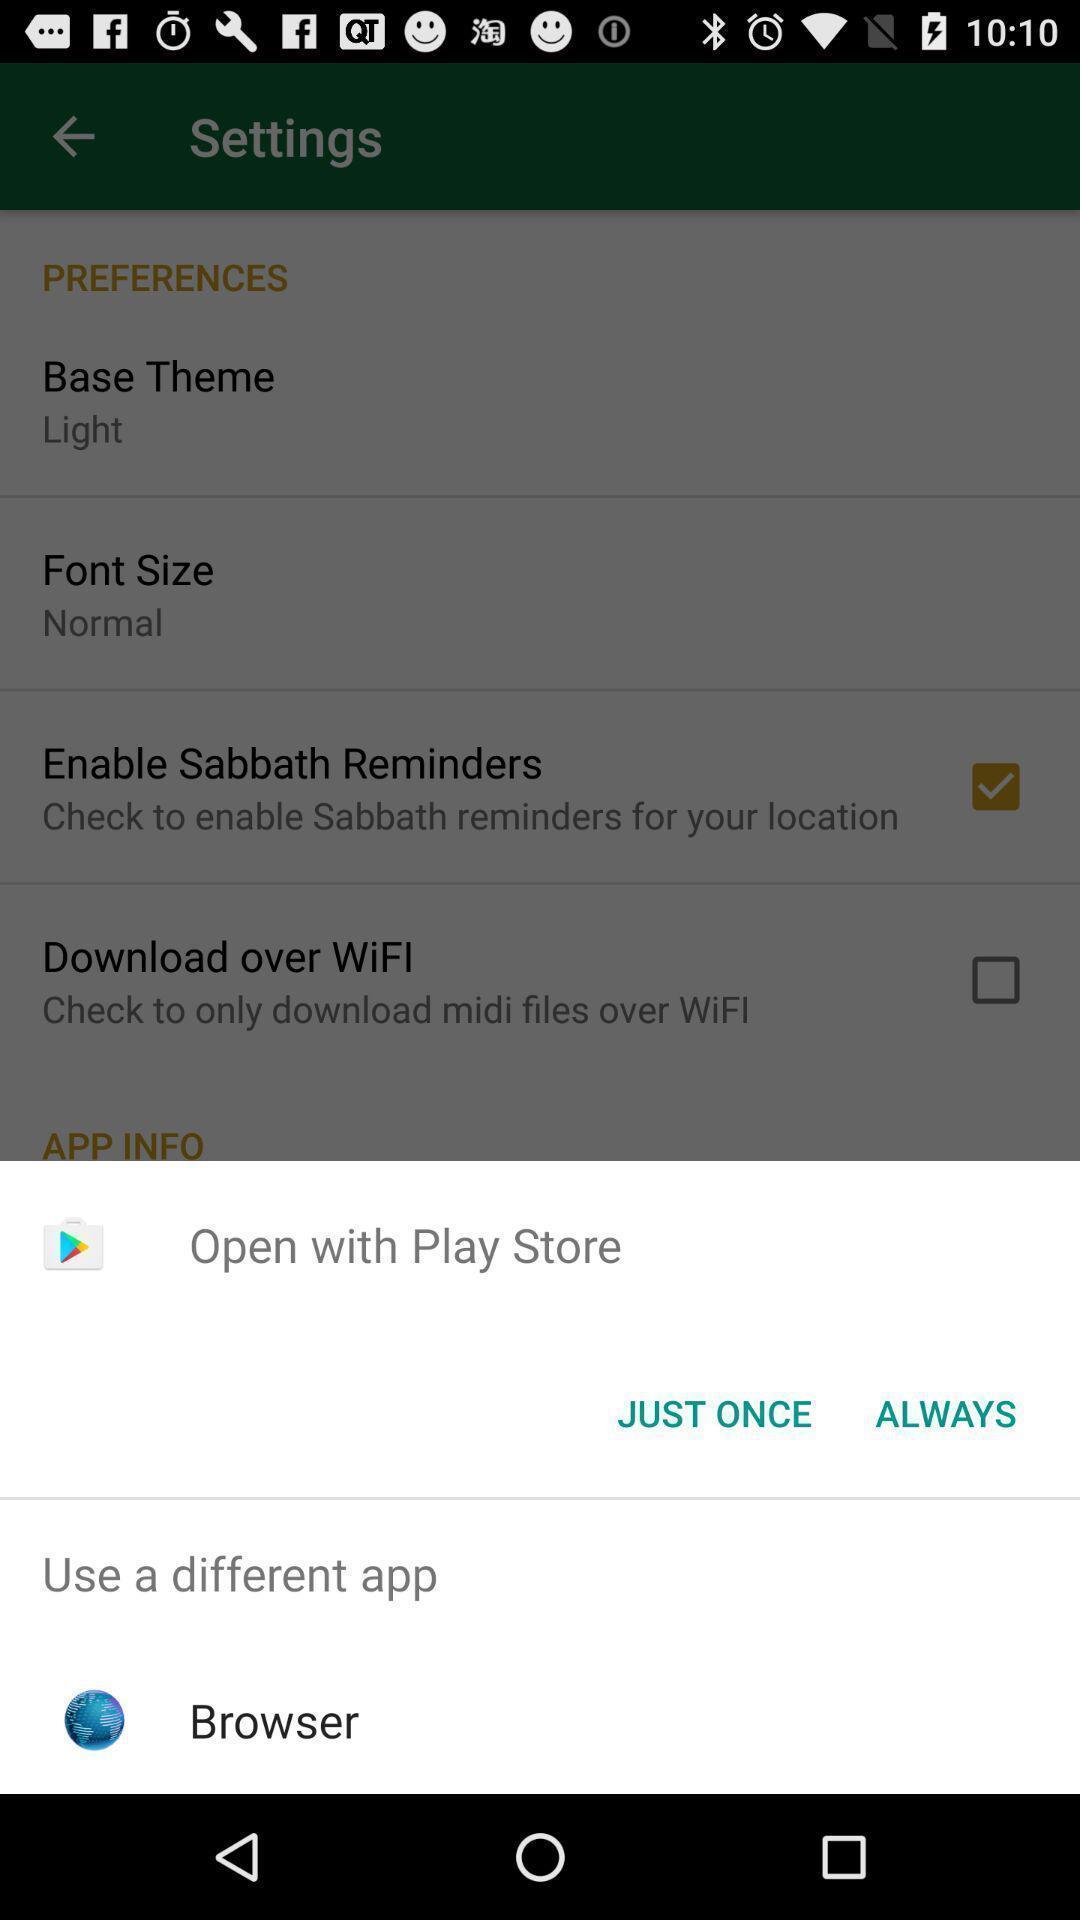What details can you identify in this image? Pop-up for open with store app once or always. 